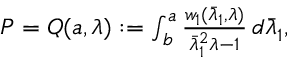Convert formula to latex. <formula><loc_0><loc_0><loc_500><loc_500>\begin{array} { r } { P = Q ( { a } , \lambda ) \colon = \int _ { b } ^ { a } \frac { w _ { 1 } ( \bar { \lambda } _ { 1 } , \lambda ) } { \bar { \lambda } _ { 1 } ^ { 2 } \lambda - 1 } \, d \bar { \lambda } _ { 1 } , } \end{array}</formula> 